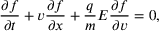Convert formula to latex. <formula><loc_0><loc_0><loc_500><loc_500>\frac { \partial f } { \partial t } + v \frac { \partial f } { \partial x } + \frac { q } { m } E \frac { \partial f } { \partial v } = 0 ,</formula> 